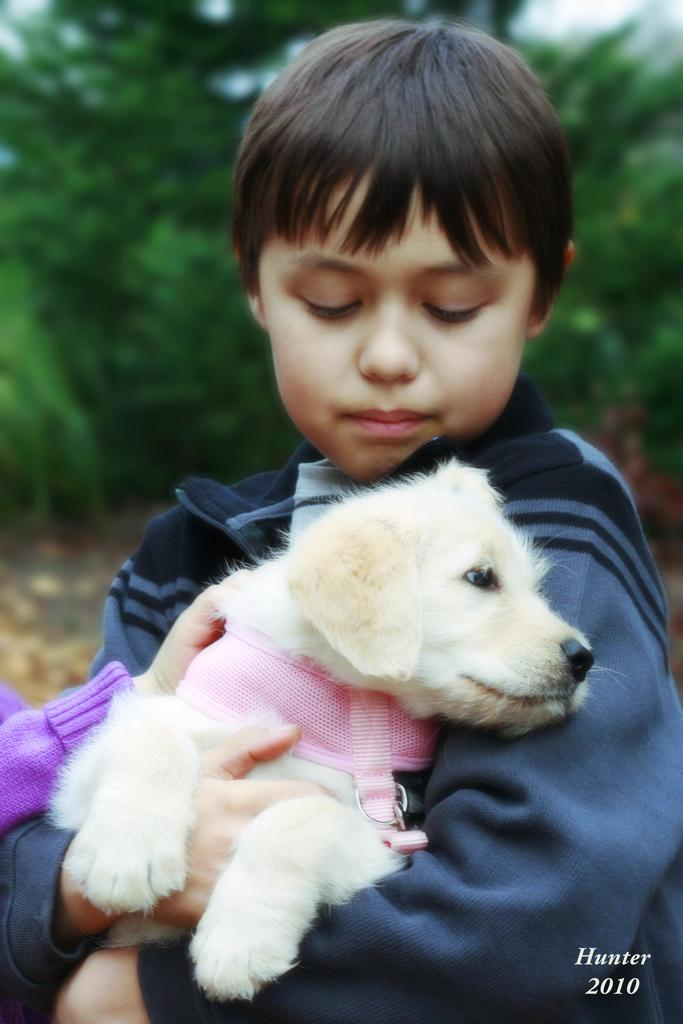Who or what is the main subject in the image? There is a person in the image. What is the person holding in the image? The person is holding a white dog. What can be seen in the background of the image? There are trees in the background of the image. What attempt is being made to drain the power in the image? There is no mention of an attempt to drain power in the image; it features a person holding a white dog with trees in the background. 